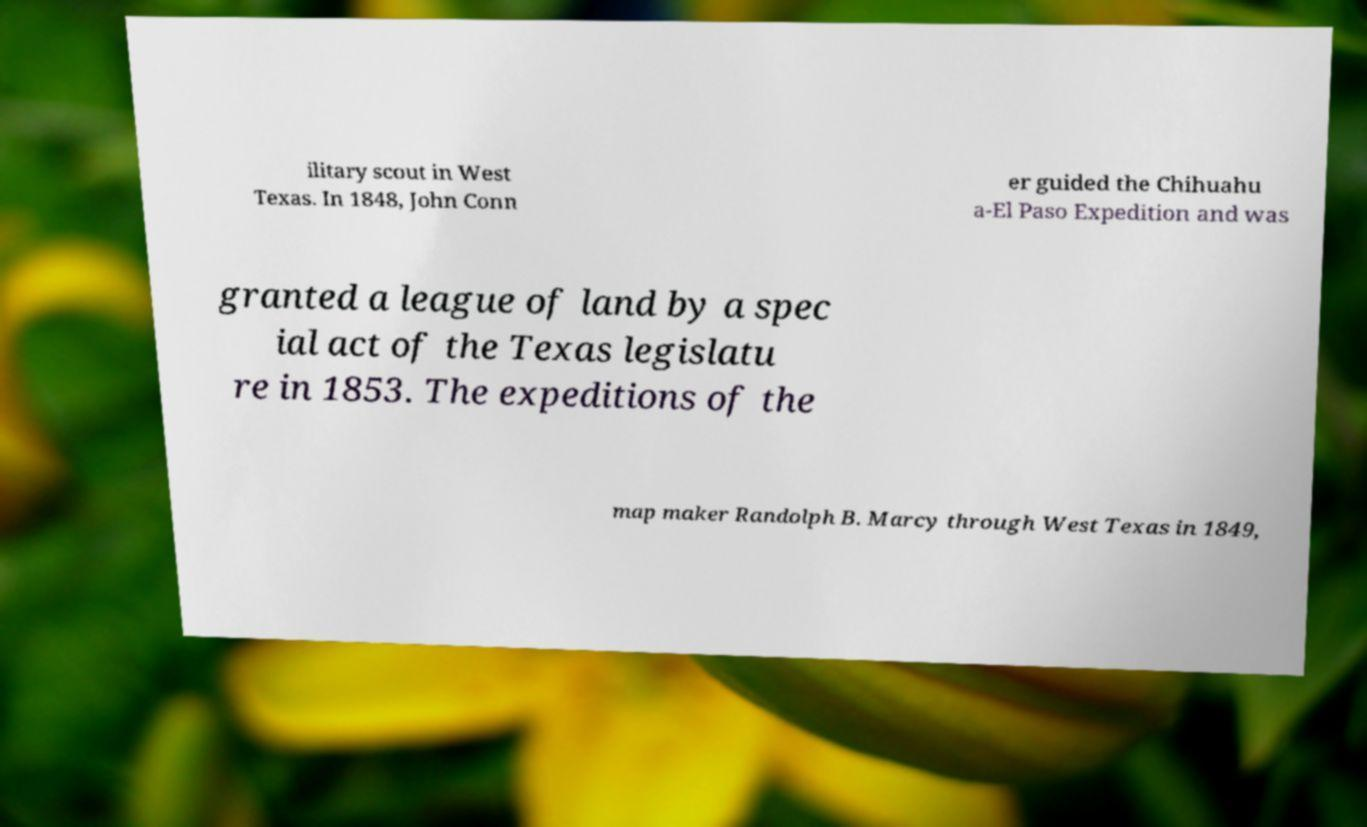Could you assist in decoding the text presented in this image and type it out clearly? ilitary scout in West Texas. In 1848, John Conn er guided the Chihuahu a-El Paso Expedition and was granted a league of land by a spec ial act of the Texas legislatu re in 1853. The expeditions of the map maker Randolph B. Marcy through West Texas in 1849, 